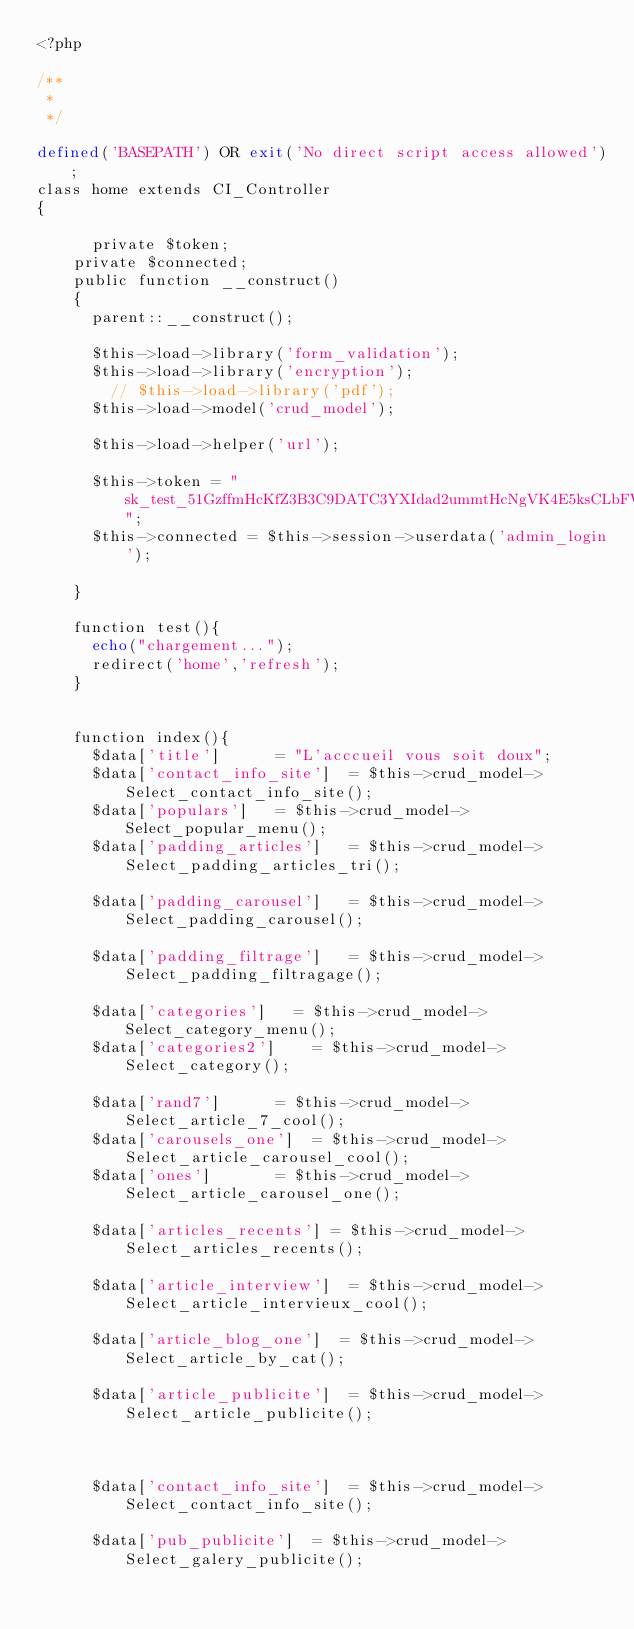<code> <loc_0><loc_0><loc_500><loc_500><_PHP_><?php 

/**
 * 
 */

defined('BASEPATH') OR exit('No direct script access allowed');  
class home extends CI_Controller
{
	
	    private $token;
		private $connected;
		public function __construct()
		{
		  parent::__construct();
		  
		  $this->load->library('form_validation');
		  $this->load->library('encryption');
	      // $this->load->library('pdf');
		  $this->load->model('crud_model'); 

		  $this->load->helper('url');

		  $this->token = "sk_test_51GzffmHcKfZ3B3C9DATC3YXIdad2ummtHcNgVK4E5ksCLbFWWLYAyXHRtVzjt8RGeejvUb6Z2yUk740hBAviBSyP00mwxmNmP1";
		  $this->connected = $this->session->userdata('admin_login');

		}

		function test(){
			echo("chargement...");
			redirect('home','refresh');
		}


		function index(){
			$data['title']			= "L'acccueil vous soit doux";
			$data['contact_info_site']  = $this->crud_model->Select_contact_info_site(); 
			$data['populars']  	= $this->crud_model->Select_popular_menu();
			$data['padding_articles']  	= $this->crud_model->Select_padding_articles_tri();

			$data['padding_carousel']  	= $this->crud_model->Select_padding_carousel();

			$data['padding_filtrage']  	= $this->crud_model->Select_padding_filtragage();
			
			$data['categories']  	= $this->crud_model->Select_category_menu();
			$data['categories2']  	= $this->crud_model->Select_category();

			$data['rand7']  		= $this->crud_model->Select_article_7_cool();
			$data['carousels_one']  = $this->crud_model->Select_article_carousel_cool();
			$data['ones'] 			= $this->crud_model->Select_article_carousel_one();

			$data['articles_recents'] = $this->crud_model->Select_articles_recents();

			$data['article_interview']  = $this->crud_model->Select_article_intervieux_cool();

			$data['article_blog_one']  = $this->crud_model->Select_article_by_cat();

			$data['article_publicite']  = $this->crud_model->Select_article_publicite();

			

			$data['contact_info_site']  = $this->crud_model->Select_contact_info_site();

			$data['pub_publicite']  = $this->crud_model->Select_galery_publicite();</code> 